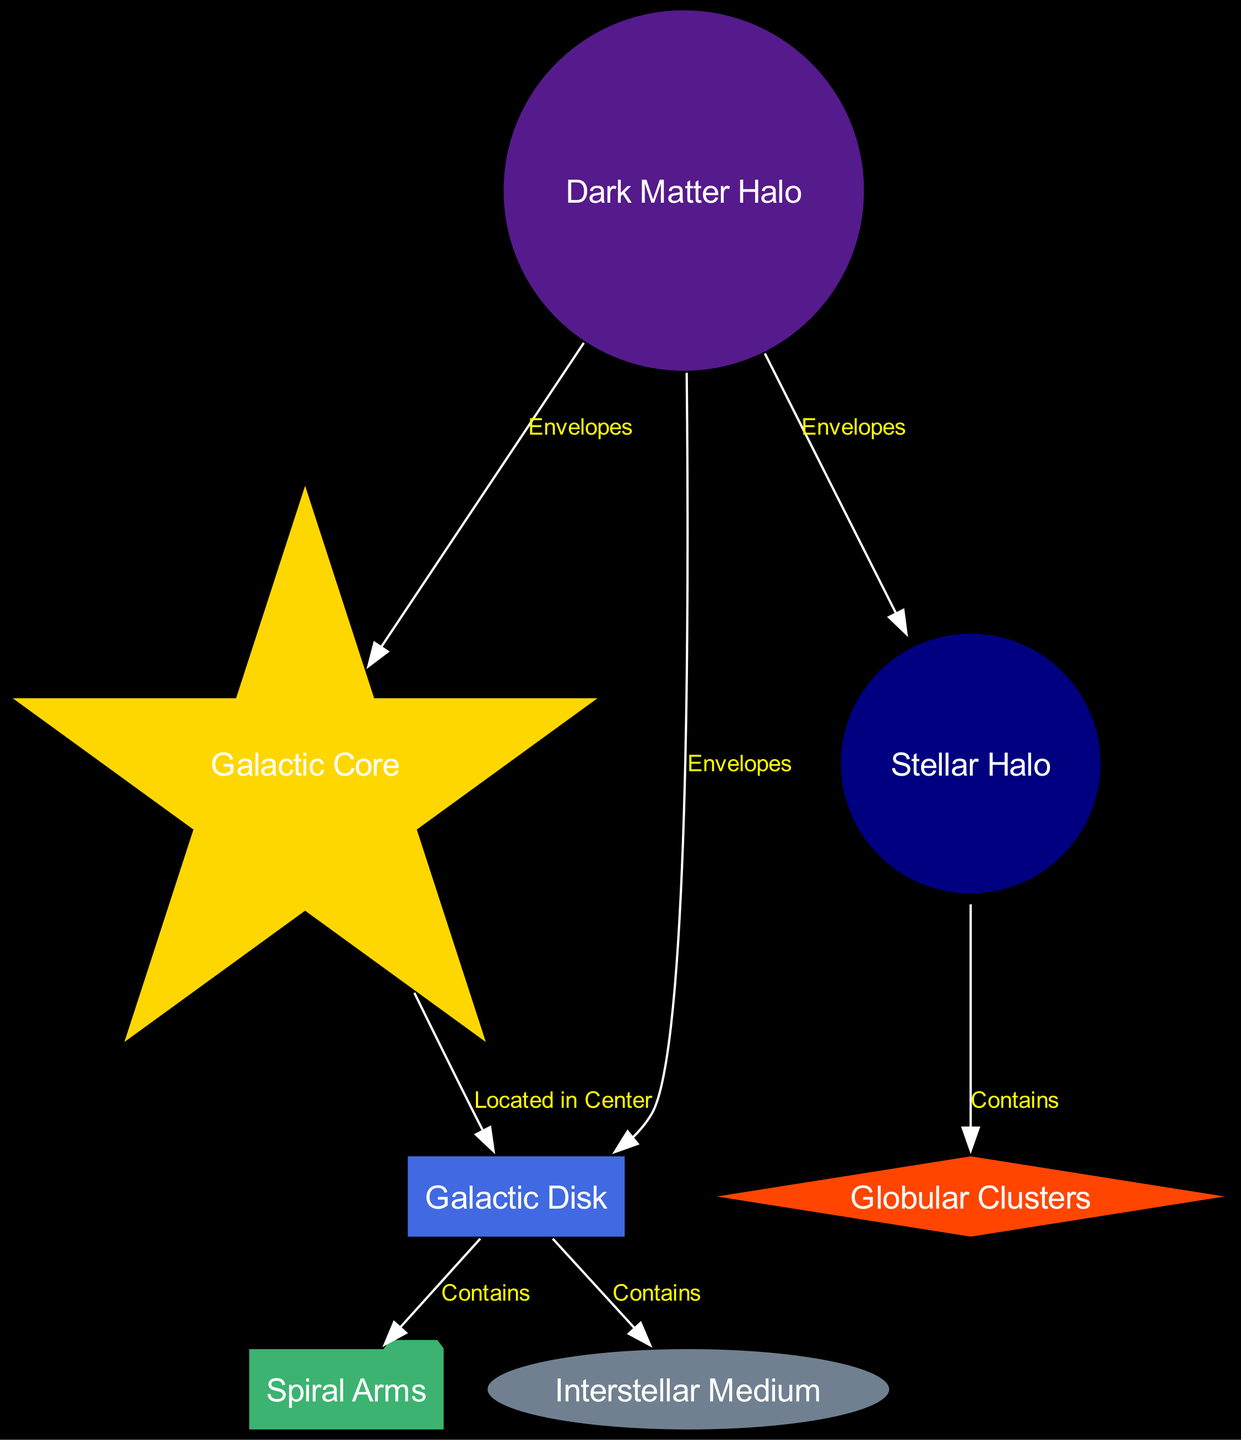What is the central region of the Milky Way called? The diagram identifies the "Galactic Core" as the central region, represented by a star-shaped node.
Answer: Galactic Core How many globular clusters are contained in the Stellar Halo? The diagram indicates that the "Globular Clusters" are a part of the "Stellar Halo," but it does not specify a number, only that globular clusters exist in that region.
Answer: Contains globular clusters Which component contains the majority of stars in the galaxy? The "Galactic Disk" is shown as the flat, rotating region that contains most of the galaxy's stars, gas, and dust.
Answer: Galactic Disk What encloses the Galactic Core? According to the diagram, the "Dark Matter Halo" is shown to envelope the "Galactic Core," indicating its surrounding influence.
Answer: Dark Matter Halo Name one of the notable spiral arms in the Galactic Disk. The diagram mentions "Perseus" and "Sagittarius" as notable spiral arms found within the "Galactic Disk."
Answer: Perseus (or Sagittarius) How does the Dark Matter Halo relate to the Galactic Disk? The diagram shows that the "Dark Matter Halo" envelopes the "Galactic Disk," indicating a protective or overarching presence over that region.
Answer: Envelopes What exists between stars in the Galactic Disk? The "Interstellar Medium" is described in the diagram as the gas and dust filling the space between stars within the "Galactic Disk."
Answer: Interstellar Medium How are the Spiral Arms depicted in relation to the Galactic Disk? The diagram states that the "Spiral Arms" are contained within the "Galactic Disk," suggesting they are regions of higher star density located within this flat region.
Answer: Contained in Galactic Disk 